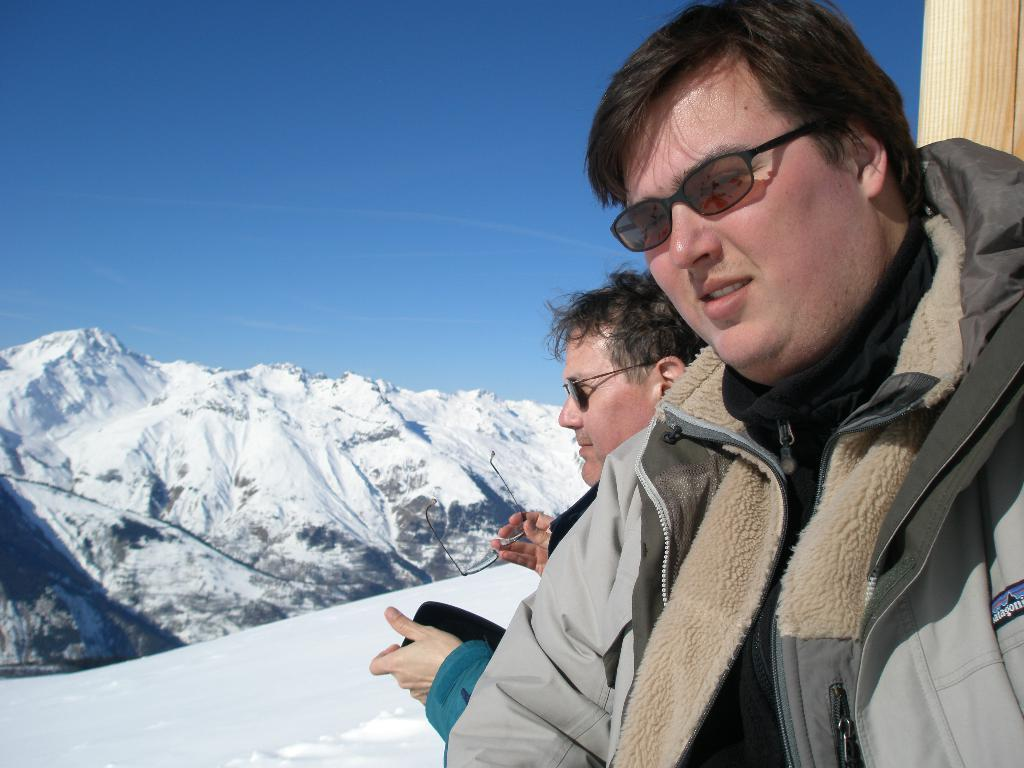Where was the picture taken? The picture was clicked outside. Can you describe the people on the right side of the image? There are two persons on the right side of the image. What can be seen in the background of the image? The sky and hills are visible in the background of the image. What is the weather like in the image? There is a lot of snow in the image, indicating a cold and snowy environment. Are there any accessories visible in the image? Yes, the spectacles are present in the image. What type of music can be heard playing in the background of the image? There is no music present in the image, as it is a still photograph. How many spiders are visible on the persons in the image? There are no spiders visible on the persons in the image. 